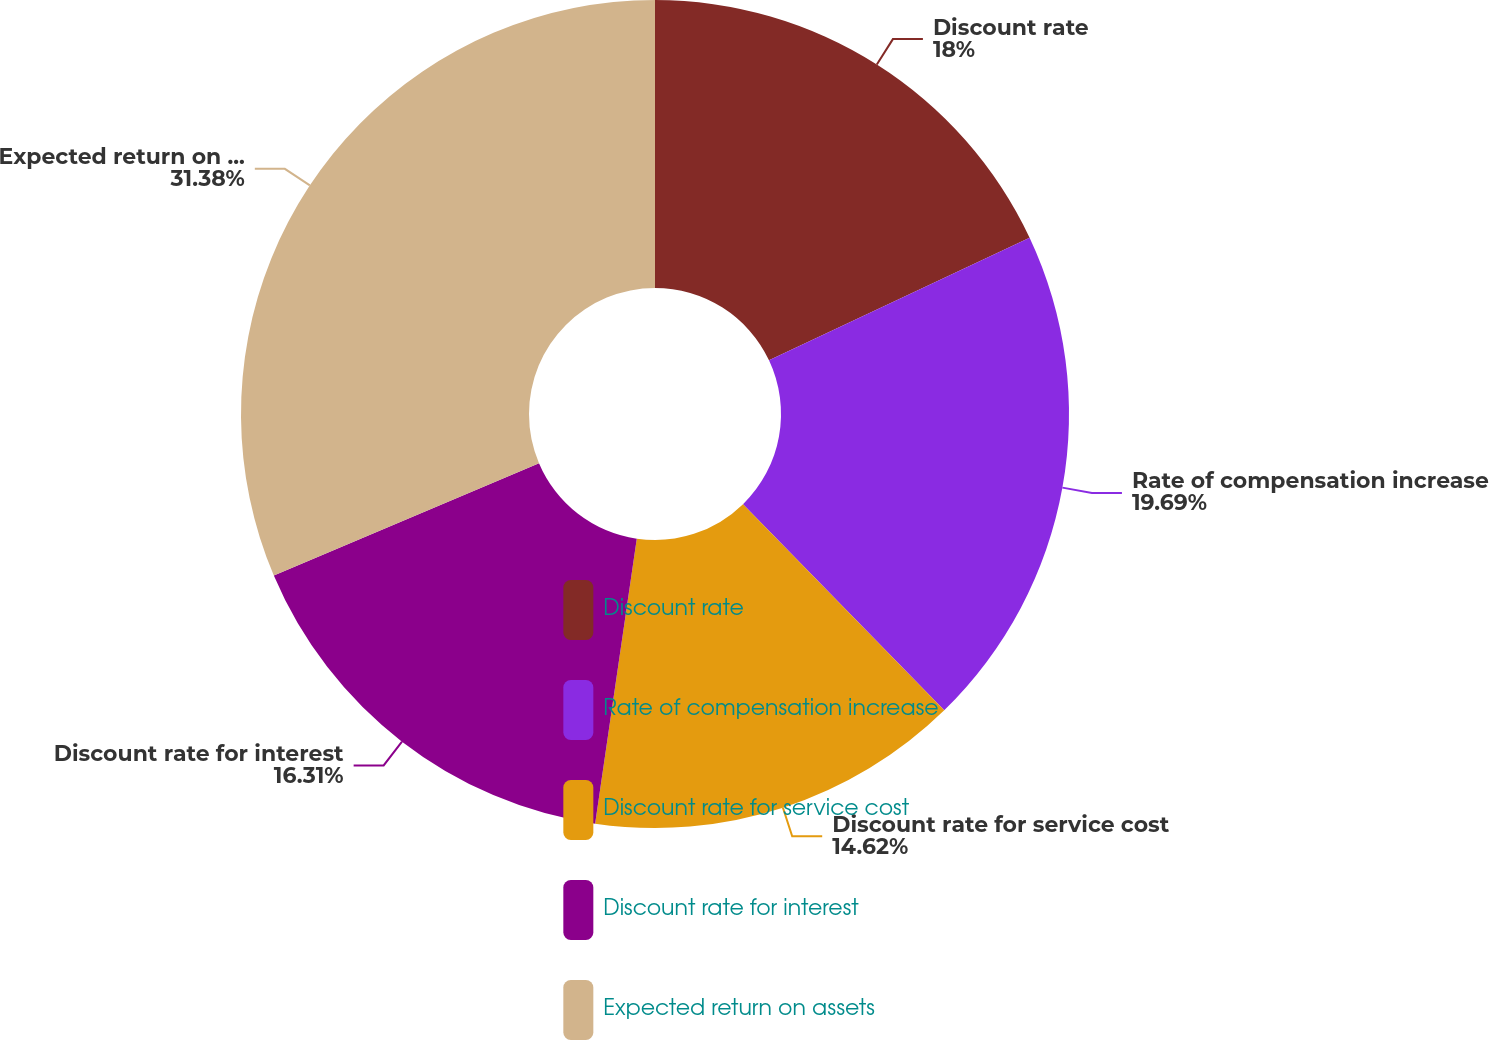Convert chart. <chart><loc_0><loc_0><loc_500><loc_500><pie_chart><fcel>Discount rate<fcel>Rate of compensation increase<fcel>Discount rate for service cost<fcel>Discount rate for interest<fcel>Expected return on assets<nl><fcel>18.0%<fcel>19.69%<fcel>14.62%<fcel>16.31%<fcel>31.38%<nl></chart> 